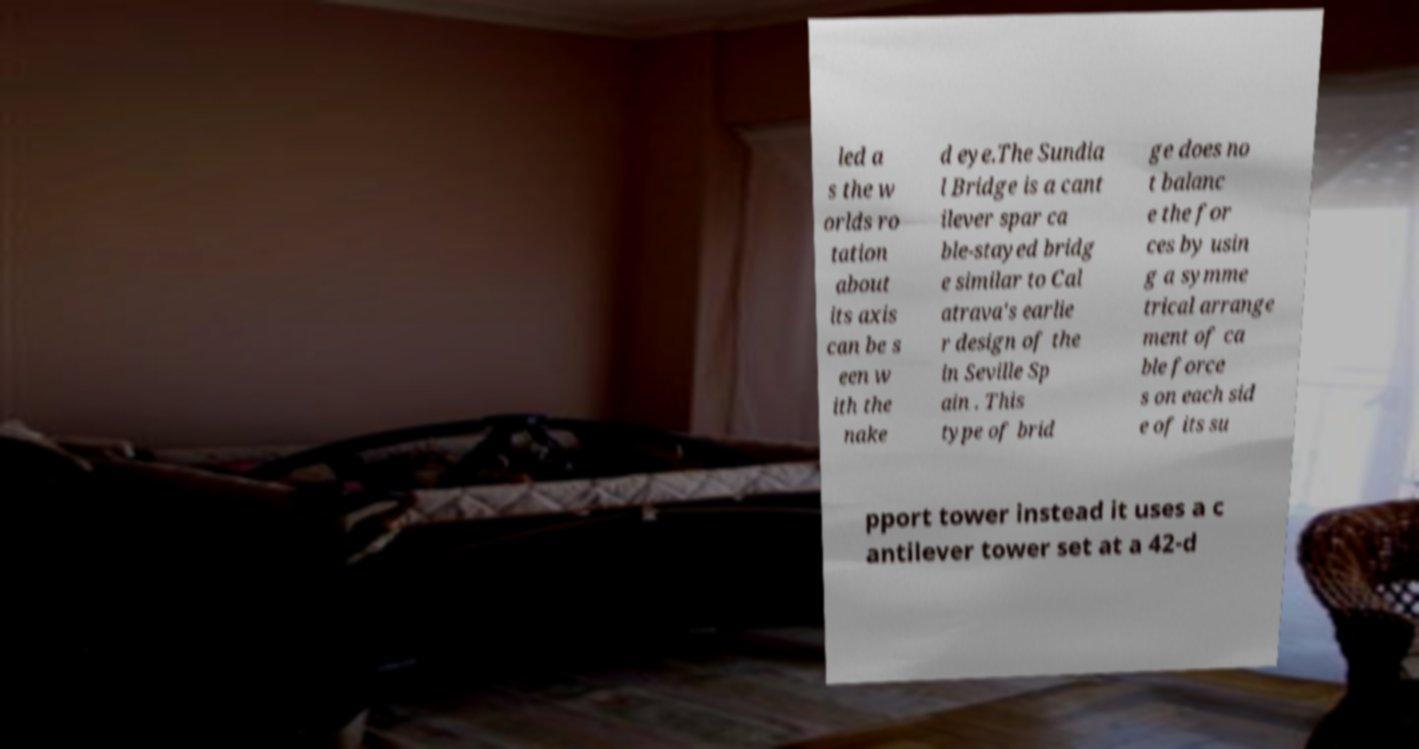For documentation purposes, I need the text within this image transcribed. Could you provide that? led a s the w orlds ro tation about its axis can be s een w ith the nake d eye.The Sundia l Bridge is a cant ilever spar ca ble-stayed bridg e similar to Cal atrava's earlie r design of the in Seville Sp ain . This type of brid ge does no t balanc e the for ces by usin g a symme trical arrange ment of ca ble force s on each sid e of its su pport tower instead it uses a c antilever tower set at a 42-d 